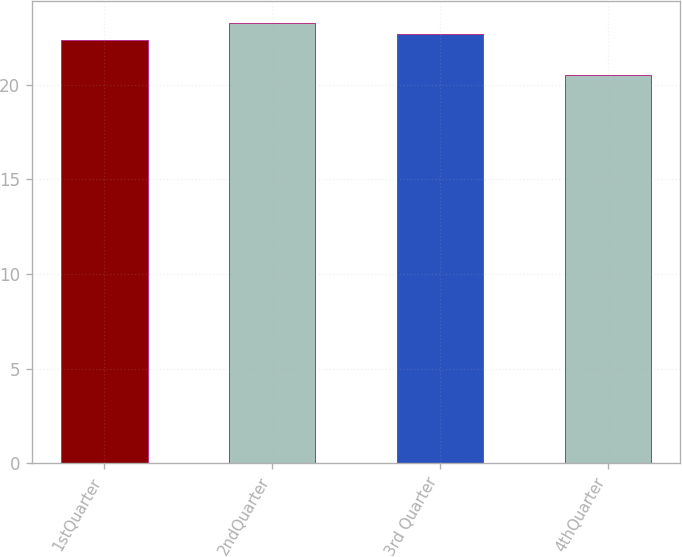<chart> <loc_0><loc_0><loc_500><loc_500><bar_chart><fcel>1stQuarter<fcel>2ndQuarter<fcel>3rd Quarter<fcel>4thQuarter<nl><fcel>22.35<fcel>23.23<fcel>22.66<fcel>20.5<nl></chart> 